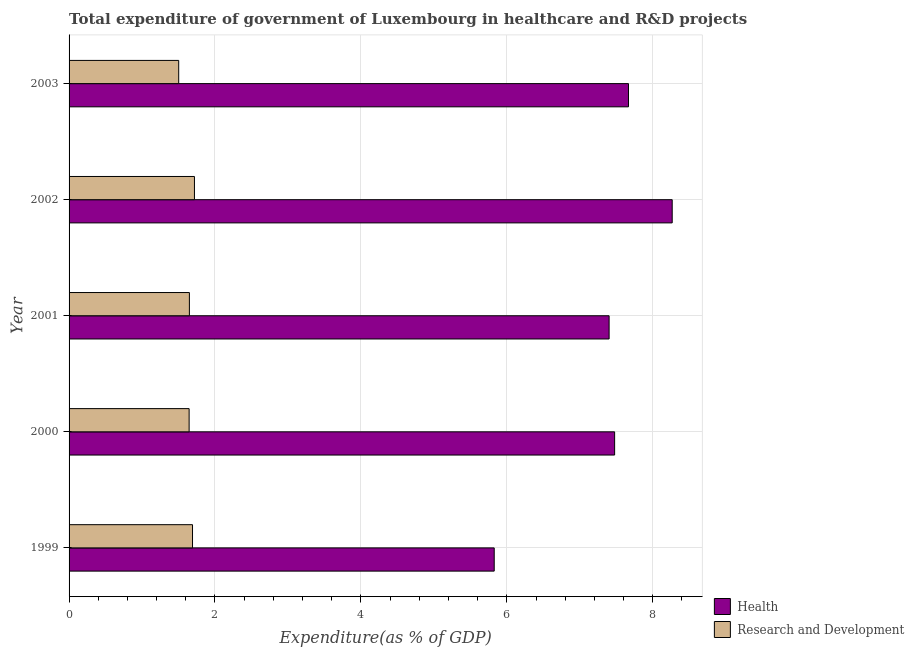How many different coloured bars are there?
Provide a short and direct response. 2. Are the number of bars per tick equal to the number of legend labels?
Offer a terse response. Yes. Are the number of bars on each tick of the Y-axis equal?
Keep it short and to the point. Yes. How many bars are there on the 3rd tick from the bottom?
Provide a short and direct response. 2. What is the label of the 4th group of bars from the top?
Keep it short and to the point. 2000. In how many cases, is the number of bars for a given year not equal to the number of legend labels?
Provide a short and direct response. 0. What is the expenditure in healthcare in 2000?
Your response must be concise. 7.48. Across all years, what is the maximum expenditure in healthcare?
Provide a short and direct response. 8.27. Across all years, what is the minimum expenditure in r&d?
Give a very brief answer. 1.5. In which year was the expenditure in healthcare minimum?
Keep it short and to the point. 1999. What is the total expenditure in healthcare in the graph?
Offer a terse response. 36.64. What is the difference between the expenditure in healthcare in 2001 and that in 2003?
Offer a very short reply. -0.27. What is the difference between the expenditure in r&d in 1999 and the expenditure in healthcare in 2001?
Give a very brief answer. -5.71. What is the average expenditure in healthcare per year?
Give a very brief answer. 7.33. In the year 2003, what is the difference between the expenditure in r&d and expenditure in healthcare?
Your response must be concise. -6.17. In how many years, is the expenditure in r&d greater than 6 %?
Keep it short and to the point. 0. Is the difference between the expenditure in r&d in 2001 and 2002 greater than the difference between the expenditure in healthcare in 2001 and 2002?
Your answer should be compact. Yes. What is the difference between the highest and the second highest expenditure in healthcare?
Your response must be concise. 0.6. What is the difference between the highest and the lowest expenditure in healthcare?
Provide a short and direct response. 2.44. What does the 1st bar from the top in 1999 represents?
Offer a terse response. Research and Development. What does the 1st bar from the bottom in 2001 represents?
Your answer should be very brief. Health. How many bars are there?
Provide a short and direct response. 10. What is the difference between two consecutive major ticks on the X-axis?
Your answer should be compact. 2. Does the graph contain any zero values?
Your answer should be compact. No. How are the legend labels stacked?
Your answer should be compact. Vertical. What is the title of the graph?
Give a very brief answer. Total expenditure of government of Luxembourg in healthcare and R&D projects. What is the label or title of the X-axis?
Your response must be concise. Expenditure(as % of GDP). What is the label or title of the Y-axis?
Keep it short and to the point. Year. What is the Expenditure(as % of GDP) of Health in 1999?
Ensure brevity in your answer.  5.83. What is the Expenditure(as % of GDP) in Research and Development in 1999?
Your answer should be very brief. 1.69. What is the Expenditure(as % of GDP) of Health in 2000?
Offer a terse response. 7.48. What is the Expenditure(as % of GDP) in Research and Development in 2000?
Give a very brief answer. 1.65. What is the Expenditure(as % of GDP) in Health in 2001?
Make the answer very short. 7.4. What is the Expenditure(as % of GDP) in Research and Development in 2001?
Offer a very short reply. 1.65. What is the Expenditure(as % of GDP) of Health in 2002?
Offer a very short reply. 8.27. What is the Expenditure(as % of GDP) of Research and Development in 2002?
Your answer should be very brief. 1.72. What is the Expenditure(as % of GDP) of Health in 2003?
Offer a terse response. 7.67. What is the Expenditure(as % of GDP) in Research and Development in 2003?
Your response must be concise. 1.5. Across all years, what is the maximum Expenditure(as % of GDP) in Health?
Your answer should be compact. 8.27. Across all years, what is the maximum Expenditure(as % of GDP) in Research and Development?
Provide a succinct answer. 1.72. Across all years, what is the minimum Expenditure(as % of GDP) of Health?
Provide a succinct answer. 5.83. Across all years, what is the minimum Expenditure(as % of GDP) of Research and Development?
Your response must be concise. 1.5. What is the total Expenditure(as % of GDP) of Health in the graph?
Your answer should be compact. 36.64. What is the total Expenditure(as % of GDP) in Research and Development in the graph?
Keep it short and to the point. 8.21. What is the difference between the Expenditure(as % of GDP) in Health in 1999 and that in 2000?
Your response must be concise. -1.65. What is the difference between the Expenditure(as % of GDP) of Research and Development in 1999 and that in 2000?
Give a very brief answer. 0.05. What is the difference between the Expenditure(as % of GDP) of Health in 1999 and that in 2001?
Offer a very short reply. -1.57. What is the difference between the Expenditure(as % of GDP) in Research and Development in 1999 and that in 2001?
Provide a short and direct response. 0.04. What is the difference between the Expenditure(as % of GDP) in Health in 1999 and that in 2002?
Your answer should be very brief. -2.44. What is the difference between the Expenditure(as % of GDP) of Research and Development in 1999 and that in 2002?
Provide a short and direct response. -0.03. What is the difference between the Expenditure(as % of GDP) of Health in 1999 and that in 2003?
Make the answer very short. -1.84. What is the difference between the Expenditure(as % of GDP) of Research and Development in 1999 and that in 2003?
Keep it short and to the point. 0.19. What is the difference between the Expenditure(as % of GDP) of Health in 2000 and that in 2001?
Your answer should be very brief. 0.08. What is the difference between the Expenditure(as % of GDP) of Research and Development in 2000 and that in 2001?
Offer a very short reply. -0. What is the difference between the Expenditure(as % of GDP) in Health in 2000 and that in 2002?
Give a very brief answer. -0.79. What is the difference between the Expenditure(as % of GDP) of Research and Development in 2000 and that in 2002?
Offer a very short reply. -0.07. What is the difference between the Expenditure(as % of GDP) of Health in 2000 and that in 2003?
Ensure brevity in your answer.  -0.19. What is the difference between the Expenditure(as % of GDP) of Research and Development in 2000 and that in 2003?
Provide a short and direct response. 0.14. What is the difference between the Expenditure(as % of GDP) in Health in 2001 and that in 2002?
Your answer should be compact. -0.86. What is the difference between the Expenditure(as % of GDP) in Research and Development in 2001 and that in 2002?
Your answer should be very brief. -0.07. What is the difference between the Expenditure(as % of GDP) of Health in 2001 and that in 2003?
Your answer should be compact. -0.27. What is the difference between the Expenditure(as % of GDP) in Research and Development in 2001 and that in 2003?
Offer a terse response. 0.15. What is the difference between the Expenditure(as % of GDP) of Health in 2002 and that in 2003?
Your response must be concise. 0.6. What is the difference between the Expenditure(as % of GDP) in Research and Development in 2002 and that in 2003?
Offer a very short reply. 0.22. What is the difference between the Expenditure(as % of GDP) in Health in 1999 and the Expenditure(as % of GDP) in Research and Development in 2000?
Your response must be concise. 4.18. What is the difference between the Expenditure(as % of GDP) of Health in 1999 and the Expenditure(as % of GDP) of Research and Development in 2001?
Ensure brevity in your answer.  4.18. What is the difference between the Expenditure(as % of GDP) of Health in 1999 and the Expenditure(as % of GDP) of Research and Development in 2002?
Your answer should be compact. 4.11. What is the difference between the Expenditure(as % of GDP) in Health in 1999 and the Expenditure(as % of GDP) in Research and Development in 2003?
Your response must be concise. 4.32. What is the difference between the Expenditure(as % of GDP) in Health in 2000 and the Expenditure(as % of GDP) in Research and Development in 2001?
Offer a very short reply. 5.83. What is the difference between the Expenditure(as % of GDP) in Health in 2000 and the Expenditure(as % of GDP) in Research and Development in 2002?
Offer a terse response. 5.76. What is the difference between the Expenditure(as % of GDP) in Health in 2000 and the Expenditure(as % of GDP) in Research and Development in 2003?
Keep it short and to the point. 5.97. What is the difference between the Expenditure(as % of GDP) of Health in 2001 and the Expenditure(as % of GDP) of Research and Development in 2002?
Your response must be concise. 5.68. What is the difference between the Expenditure(as % of GDP) of Health in 2001 and the Expenditure(as % of GDP) of Research and Development in 2003?
Your answer should be very brief. 5.9. What is the difference between the Expenditure(as % of GDP) in Health in 2002 and the Expenditure(as % of GDP) in Research and Development in 2003?
Ensure brevity in your answer.  6.76. What is the average Expenditure(as % of GDP) in Health per year?
Your response must be concise. 7.33. What is the average Expenditure(as % of GDP) in Research and Development per year?
Ensure brevity in your answer.  1.64. In the year 1999, what is the difference between the Expenditure(as % of GDP) of Health and Expenditure(as % of GDP) of Research and Development?
Offer a terse response. 4.14. In the year 2000, what is the difference between the Expenditure(as % of GDP) of Health and Expenditure(as % of GDP) of Research and Development?
Offer a terse response. 5.83. In the year 2001, what is the difference between the Expenditure(as % of GDP) in Health and Expenditure(as % of GDP) in Research and Development?
Make the answer very short. 5.75. In the year 2002, what is the difference between the Expenditure(as % of GDP) of Health and Expenditure(as % of GDP) of Research and Development?
Provide a short and direct response. 6.55. In the year 2003, what is the difference between the Expenditure(as % of GDP) of Health and Expenditure(as % of GDP) of Research and Development?
Your answer should be very brief. 6.16. What is the ratio of the Expenditure(as % of GDP) of Health in 1999 to that in 2000?
Your answer should be very brief. 0.78. What is the ratio of the Expenditure(as % of GDP) of Research and Development in 1999 to that in 2000?
Keep it short and to the point. 1.03. What is the ratio of the Expenditure(as % of GDP) of Health in 1999 to that in 2001?
Your answer should be very brief. 0.79. What is the ratio of the Expenditure(as % of GDP) in Research and Development in 1999 to that in 2001?
Keep it short and to the point. 1.03. What is the ratio of the Expenditure(as % of GDP) in Health in 1999 to that in 2002?
Your answer should be compact. 0.7. What is the ratio of the Expenditure(as % of GDP) in Research and Development in 1999 to that in 2002?
Offer a very short reply. 0.98. What is the ratio of the Expenditure(as % of GDP) in Health in 1999 to that in 2003?
Offer a very short reply. 0.76. What is the ratio of the Expenditure(as % of GDP) in Research and Development in 1999 to that in 2003?
Provide a succinct answer. 1.13. What is the ratio of the Expenditure(as % of GDP) in Health in 2000 to that in 2001?
Your response must be concise. 1.01. What is the ratio of the Expenditure(as % of GDP) of Health in 2000 to that in 2002?
Provide a short and direct response. 0.9. What is the ratio of the Expenditure(as % of GDP) of Research and Development in 2000 to that in 2002?
Offer a terse response. 0.96. What is the ratio of the Expenditure(as % of GDP) of Health in 2000 to that in 2003?
Provide a succinct answer. 0.98. What is the ratio of the Expenditure(as % of GDP) in Research and Development in 2000 to that in 2003?
Your response must be concise. 1.1. What is the ratio of the Expenditure(as % of GDP) in Health in 2001 to that in 2002?
Offer a very short reply. 0.9. What is the ratio of the Expenditure(as % of GDP) in Research and Development in 2001 to that in 2002?
Provide a succinct answer. 0.96. What is the ratio of the Expenditure(as % of GDP) in Health in 2001 to that in 2003?
Keep it short and to the point. 0.97. What is the ratio of the Expenditure(as % of GDP) of Research and Development in 2001 to that in 2003?
Offer a very short reply. 1.1. What is the ratio of the Expenditure(as % of GDP) in Health in 2002 to that in 2003?
Make the answer very short. 1.08. What is the ratio of the Expenditure(as % of GDP) in Research and Development in 2002 to that in 2003?
Your answer should be compact. 1.14. What is the difference between the highest and the second highest Expenditure(as % of GDP) in Health?
Keep it short and to the point. 0.6. What is the difference between the highest and the second highest Expenditure(as % of GDP) in Research and Development?
Keep it short and to the point. 0.03. What is the difference between the highest and the lowest Expenditure(as % of GDP) of Health?
Your answer should be compact. 2.44. What is the difference between the highest and the lowest Expenditure(as % of GDP) of Research and Development?
Ensure brevity in your answer.  0.22. 